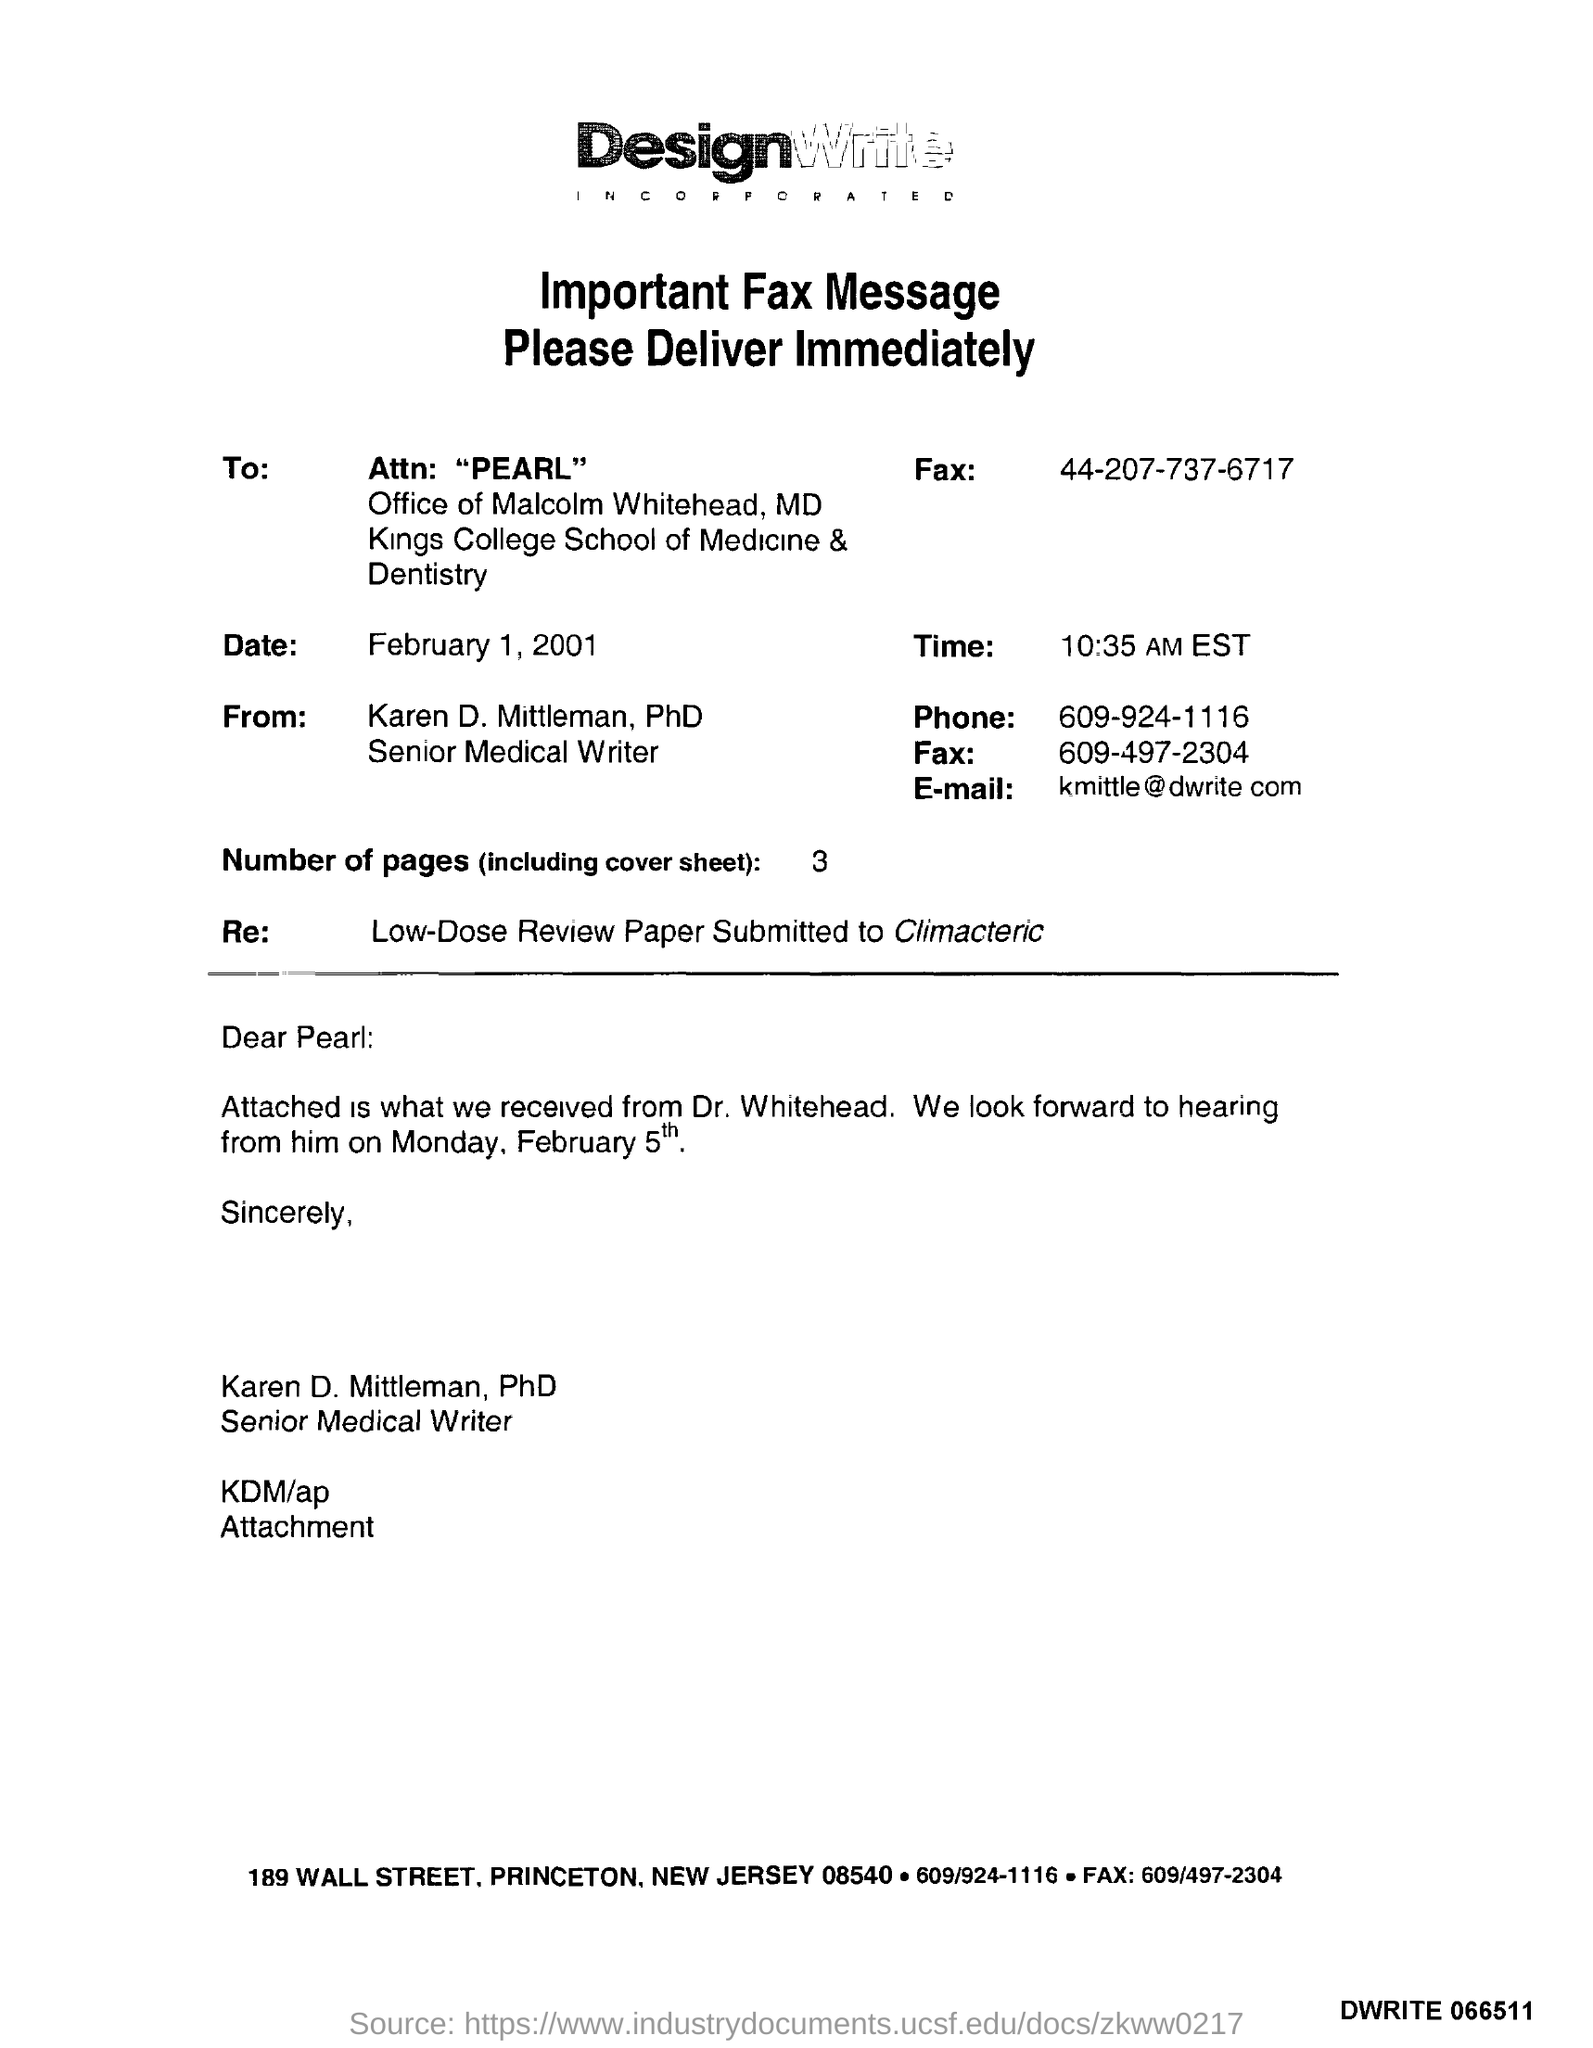What day if February 5th?
Your response must be concise. Monday. 